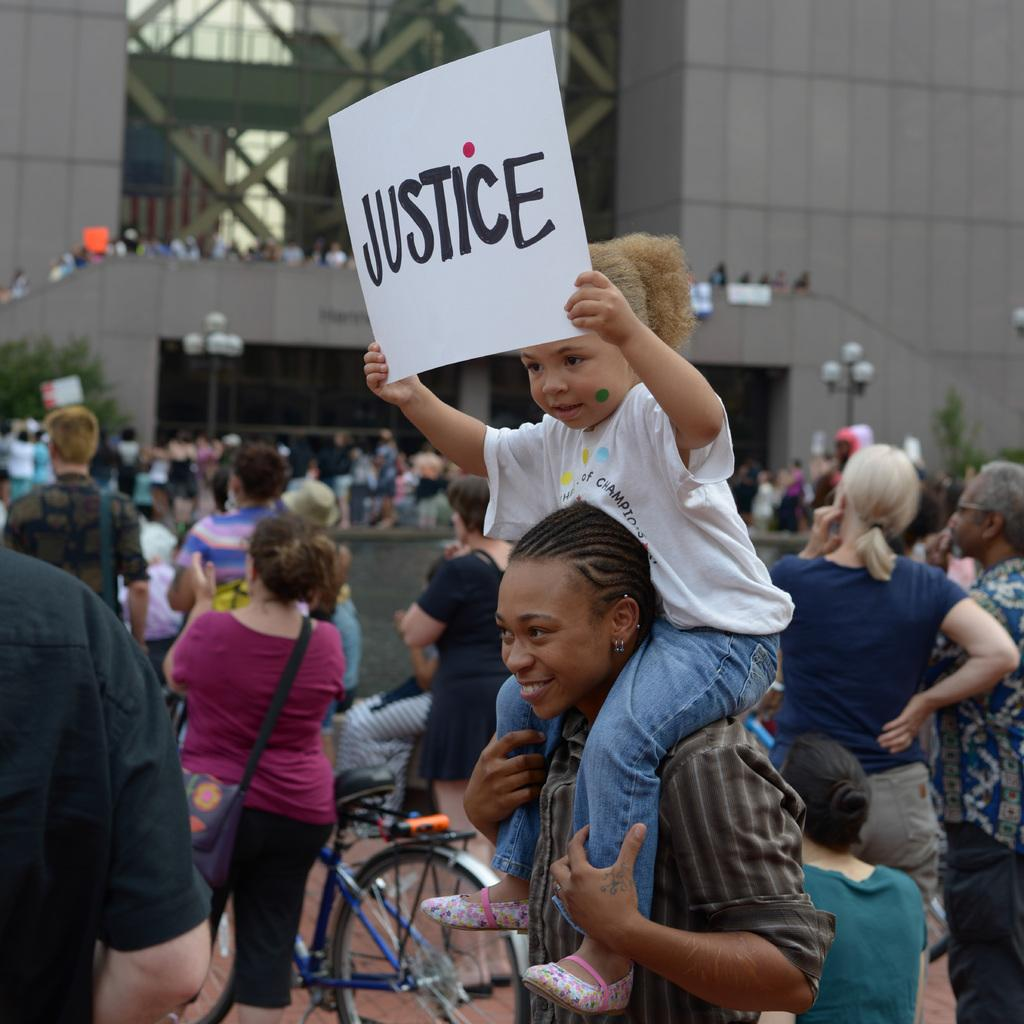How many people are in the group visible in the image? There is a group of people in the image, but the exact number is not specified. What can be seen besides the group of people in the image? There is a bicycle, a bottle, a bag, and a girl holding a poster in the image. What is the girl holding in the image? The girl is holding a poster in the image. What can be seen in the background of the image? There is a building, light poles, trees, and some unspecified objects in the background of the image. What type of plant is growing on the authority figure in the image? There is no authority figure or plant present in the image. What type of soap is being used by the girl holding the poster in the image? There is no soap present in the image; the girl is holding a poster. 